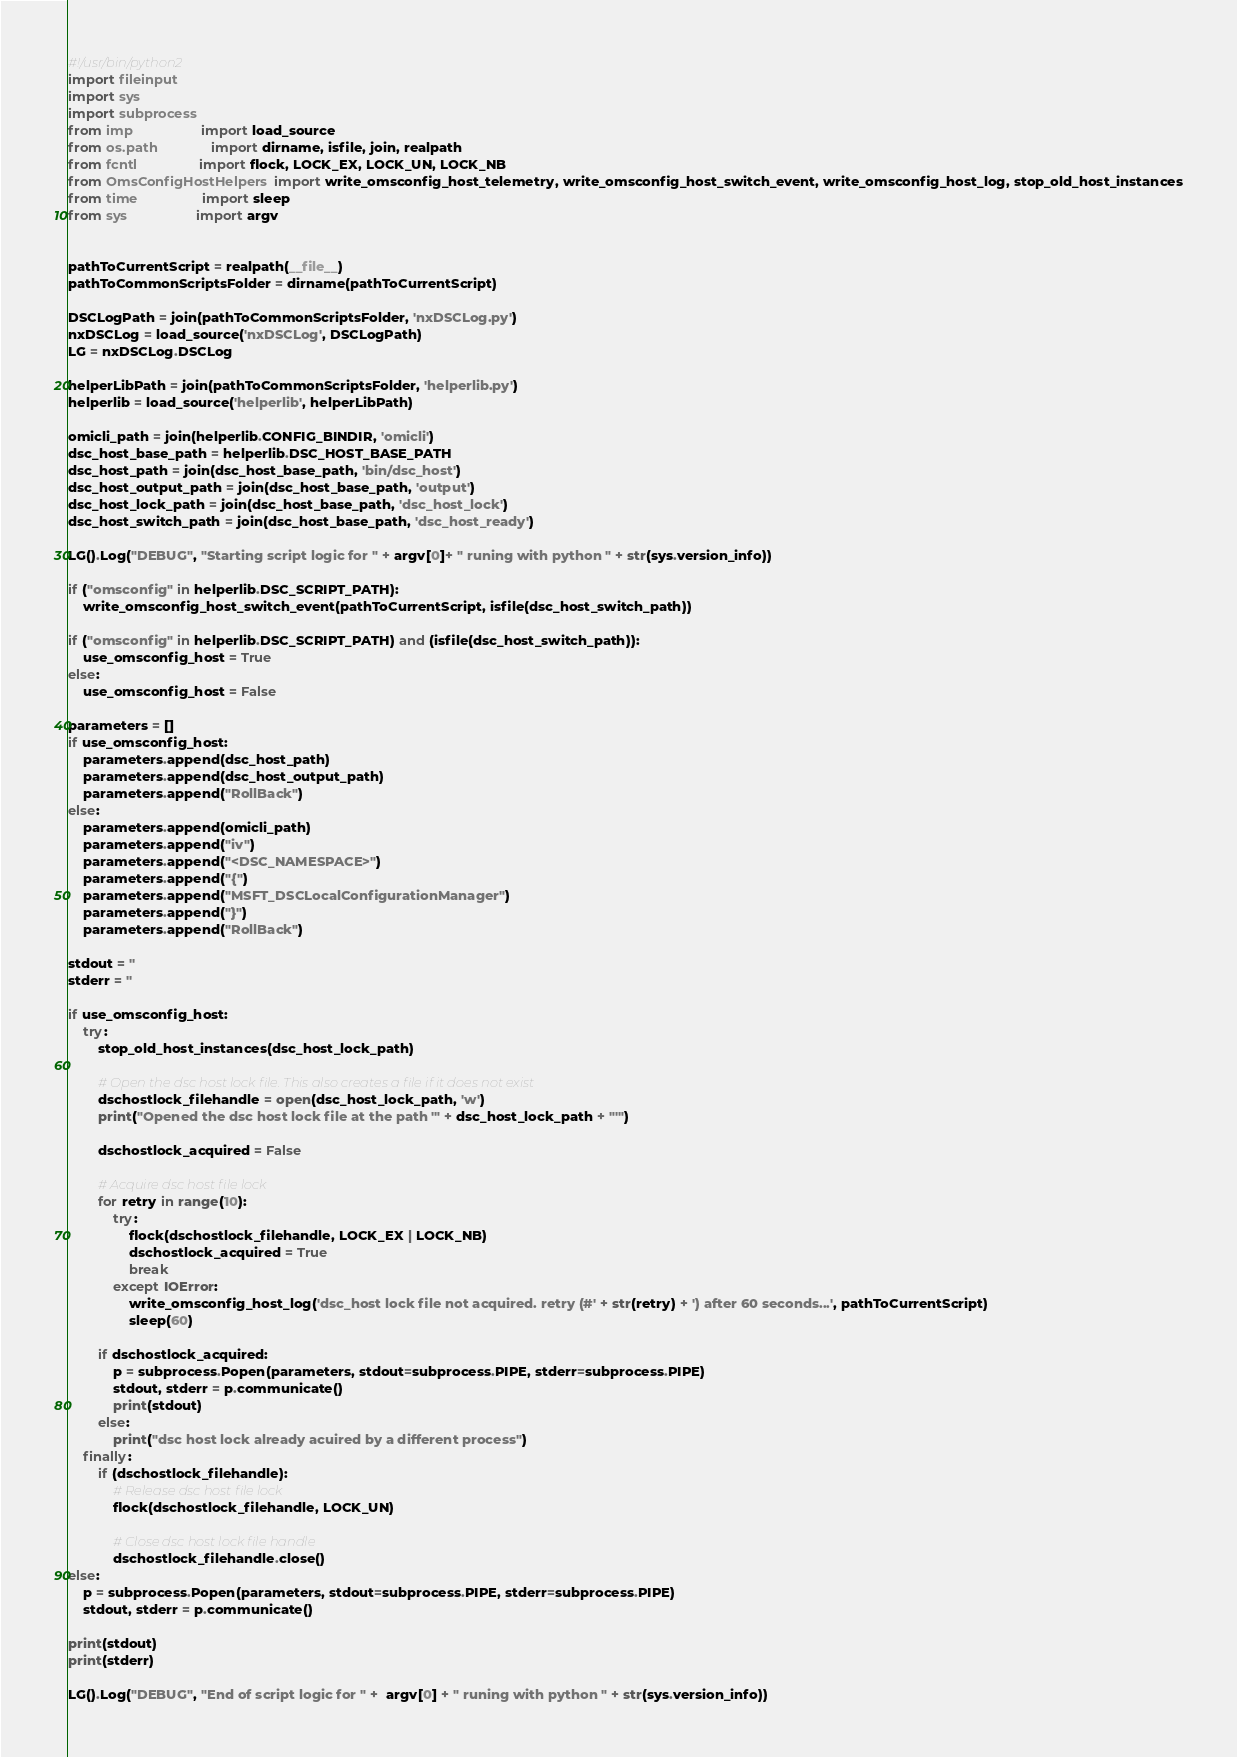Convert code to text. <code><loc_0><loc_0><loc_500><loc_500><_Python_>#!/usr/bin/python2
import fileinput
import sys
import subprocess
from imp                  import load_source
from os.path              import dirname, isfile, join, realpath
from fcntl                import flock, LOCK_EX, LOCK_UN, LOCK_NB
from OmsConfigHostHelpers import write_omsconfig_host_telemetry, write_omsconfig_host_switch_event, write_omsconfig_host_log, stop_old_host_instances
from time                 import sleep
from sys                  import argv


pathToCurrentScript = realpath(__file__)
pathToCommonScriptsFolder = dirname(pathToCurrentScript)

DSCLogPath = join(pathToCommonScriptsFolder, 'nxDSCLog.py')
nxDSCLog = load_source('nxDSCLog', DSCLogPath)
LG = nxDSCLog.DSCLog

helperLibPath = join(pathToCommonScriptsFolder, 'helperlib.py')
helperlib = load_source('helperlib', helperLibPath)

omicli_path = join(helperlib.CONFIG_BINDIR, 'omicli')
dsc_host_base_path = helperlib.DSC_HOST_BASE_PATH
dsc_host_path = join(dsc_host_base_path, 'bin/dsc_host')
dsc_host_output_path = join(dsc_host_base_path, 'output')
dsc_host_lock_path = join(dsc_host_base_path, 'dsc_host_lock')
dsc_host_switch_path = join(dsc_host_base_path, 'dsc_host_ready')

LG().Log("DEBUG", "Starting script logic for " + argv[0]+ " runing with python " + str(sys.version_info))

if ("omsconfig" in helperlib.DSC_SCRIPT_PATH):
    write_omsconfig_host_switch_event(pathToCurrentScript, isfile(dsc_host_switch_path))

if ("omsconfig" in helperlib.DSC_SCRIPT_PATH) and (isfile(dsc_host_switch_path)):
    use_omsconfig_host = True
else:
    use_omsconfig_host = False

parameters = []
if use_omsconfig_host:
    parameters.append(dsc_host_path)
    parameters.append(dsc_host_output_path)
    parameters.append("RollBack")
else:
    parameters.append(omicli_path)
    parameters.append("iv")
    parameters.append("<DSC_NAMESPACE>")
    parameters.append("{")
    parameters.append("MSFT_DSCLocalConfigurationManager")
    parameters.append("}")
    parameters.append("RollBack")

stdout = ''
stderr = ''

if use_omsconfig_host:
    try:
        stop_old_host_instances(dsc_host_lock_path)

        # Open the dsc host lock file. This also creates a file if it does not exist
        dschostlock_filehandle = open(dsc_host_lock_path, 'w')
        print("Opened the dsc host lock file at the path '" + dsc_host_lock_path + "'")
        
        dschostlock_acquired = False

        # Acquire dsc host file lock
        for retry in range(10):
            try:
                flock(dschostlock_filehandle, LOCK_EX | LOCK_NB)
                dschostlock_acquired = True
                break
            except IOError:
                write_omsconfig_host_log('dsc_host lock file not acquired. retry (#' + str(retry) + ') after 60 seconds...', pathToCurrentScript)
                sleep(60)

        if dschostlock_acquired:
            p = subprocess.Popen(parameters, stdout=subprocess.PIPE, stderr=subprocess.PIPE)
            stdout, stderr = p.communicate()
            print(stdout)
        else:
            print("dsc host lock already acuired by a different process")
    finally:
        if (dschostlock_filehandle):
            # Release dsc host file lock
            flock(dschostlock_filehandle, LOCK_UN)

            # Close dsc host lock file handle
            dschostlock_filehandle.close()
else:
    p = subprocess.Popen(parameters, stdout=subprocess.PIPE, stderr=subprocess.PIPE)
    stdout, stderr = p.communicate()

print(stdout)
print(stderr)

LG().Log("DEBUG", "End of script logic for " +  argv[0] + " runing with python " + str(sys.version_info))</code> 